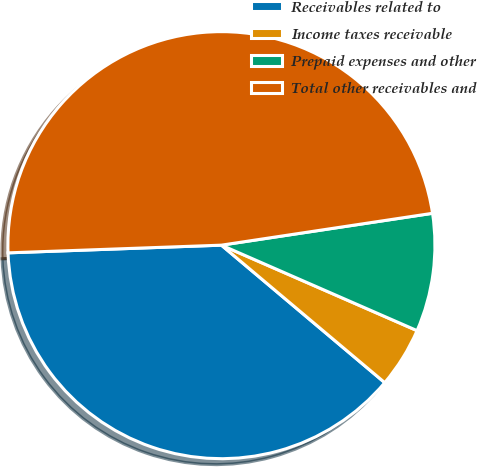<chart> <loc_0><loc_0><loc_500><loc_500><pie_chart><fcel>Receivables related to<fcel>Income taxes receivable<fcel>Prepaid expenses and other<fcel>Total other receivables and<nl><fcel>38.29%<fcel>4.58%<fcel>8.94%<fcel>48.19%<nl></chart> 